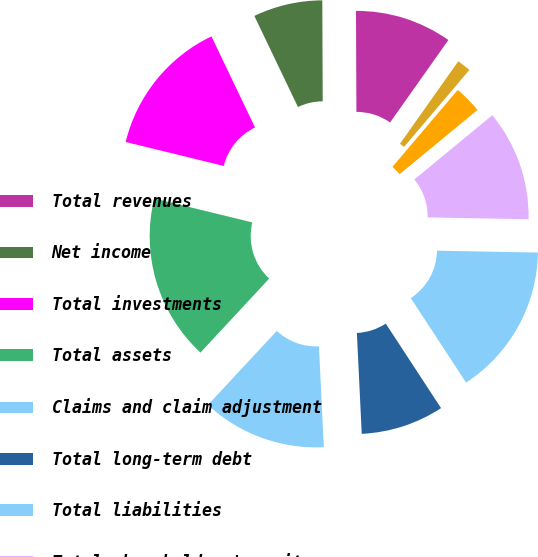Convert chart. <chart><loc_0><loc_0><loc_500><loc_500><pie_chart><fcel>Total revenues<fcel>Net income<fcel>Total investments<fcel>Total assets<fcel>Claims and claim adjustment<fcel>Total long-term debt<fcel>Total liabilities<fcel>Total shareholders' equity<fcel>Basic<fcel>Diluted<nl><fcel>9.86%<fcel>7.04%<fcel>14.08%<fcel>16.9%<fcel>12.68%<fcel>8.45%<fcel>15.49%<fcel>11.27%<fcel>2.82%<fcel>1.41%<nl></chart> 